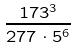<formula> <loc_0><loc_0><loc_500><loc_500>\frac { 1 7 3 ^ { 3 } } { 2 7 7 \cdot 5 ^ { 6 } }</formula> 